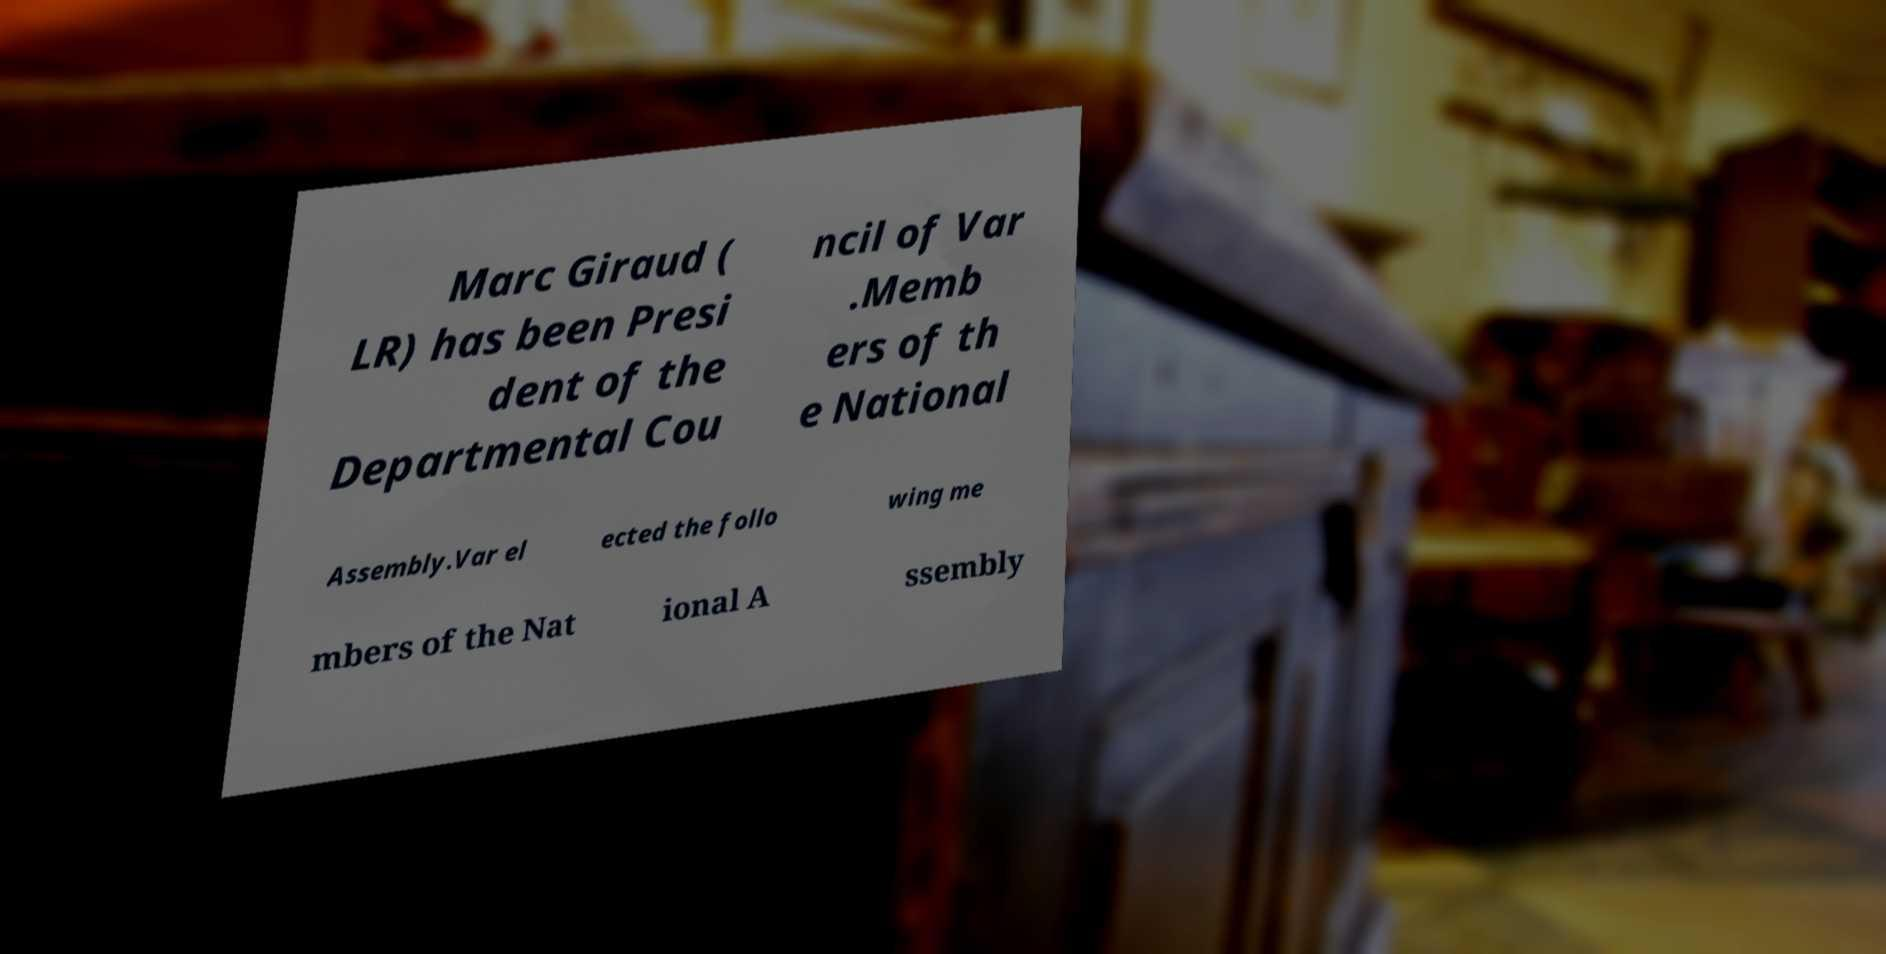What messages or text are displayed in this image? I need them in a readable, typed format. Marc Giraud ( LR) has been Presi dent of the Departmental Cou ncil of Var .Memb ers of th e National Assembly.Var el ected the follo wing me mbers of the Nat ional A ssembly 